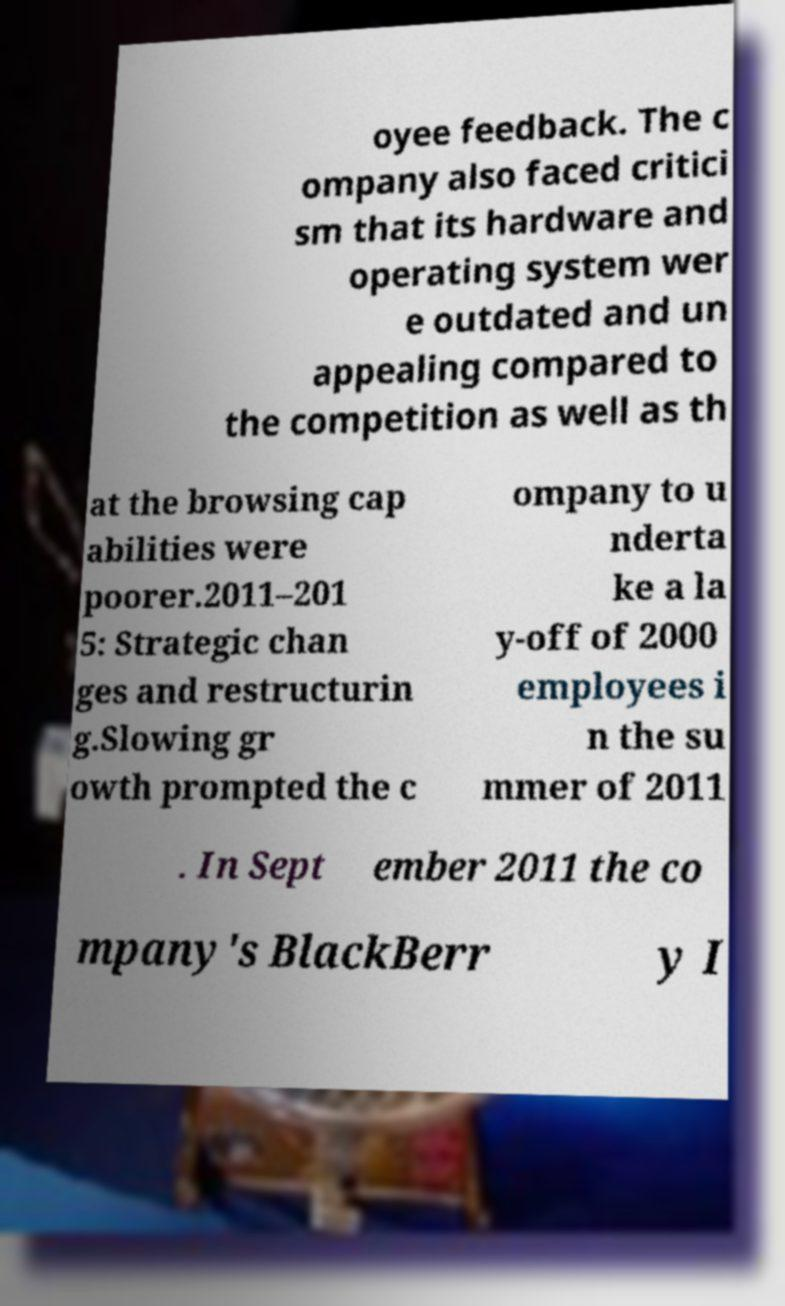Can you read and provide the text displayed in the image?This photo seems to have some interesting text. Can you extract and type it out for me? oyee feedback. The c ompany also faced critici sm that its hardware and operating system wer e outdated and un appealing compared to the competition as well as th at the browsing cap abilities were poorer.2011–201 5: Strategic chan ges and restructurin g.Slowing gr owth prompted the c ompany to u nderta ke a la y-off of 2000 employees i n the su mmer of 2011 . In Sept ember 2011 the co mpany's BlackBerr y I 